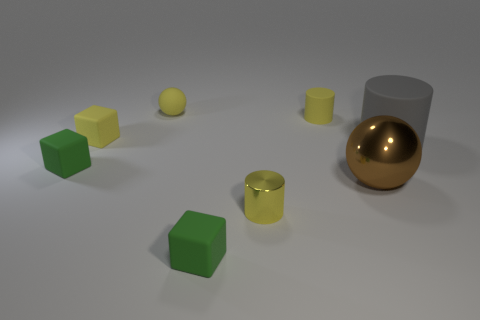Add 2 blocks. How many objects exist? 10 Subtract all cubes. How many objects are left? 5 Subtract 2 yellow cylinders. How many objects are left? 6 Subtract all small green matte cubes. Subtract all tiny balls. How many objects are left? 5 Add 6 tiny yellow rubber cubes. How many tiny yellow rubber cubes are left? 7 Add 8 large red metal things. How many large red metal things exist? 8 